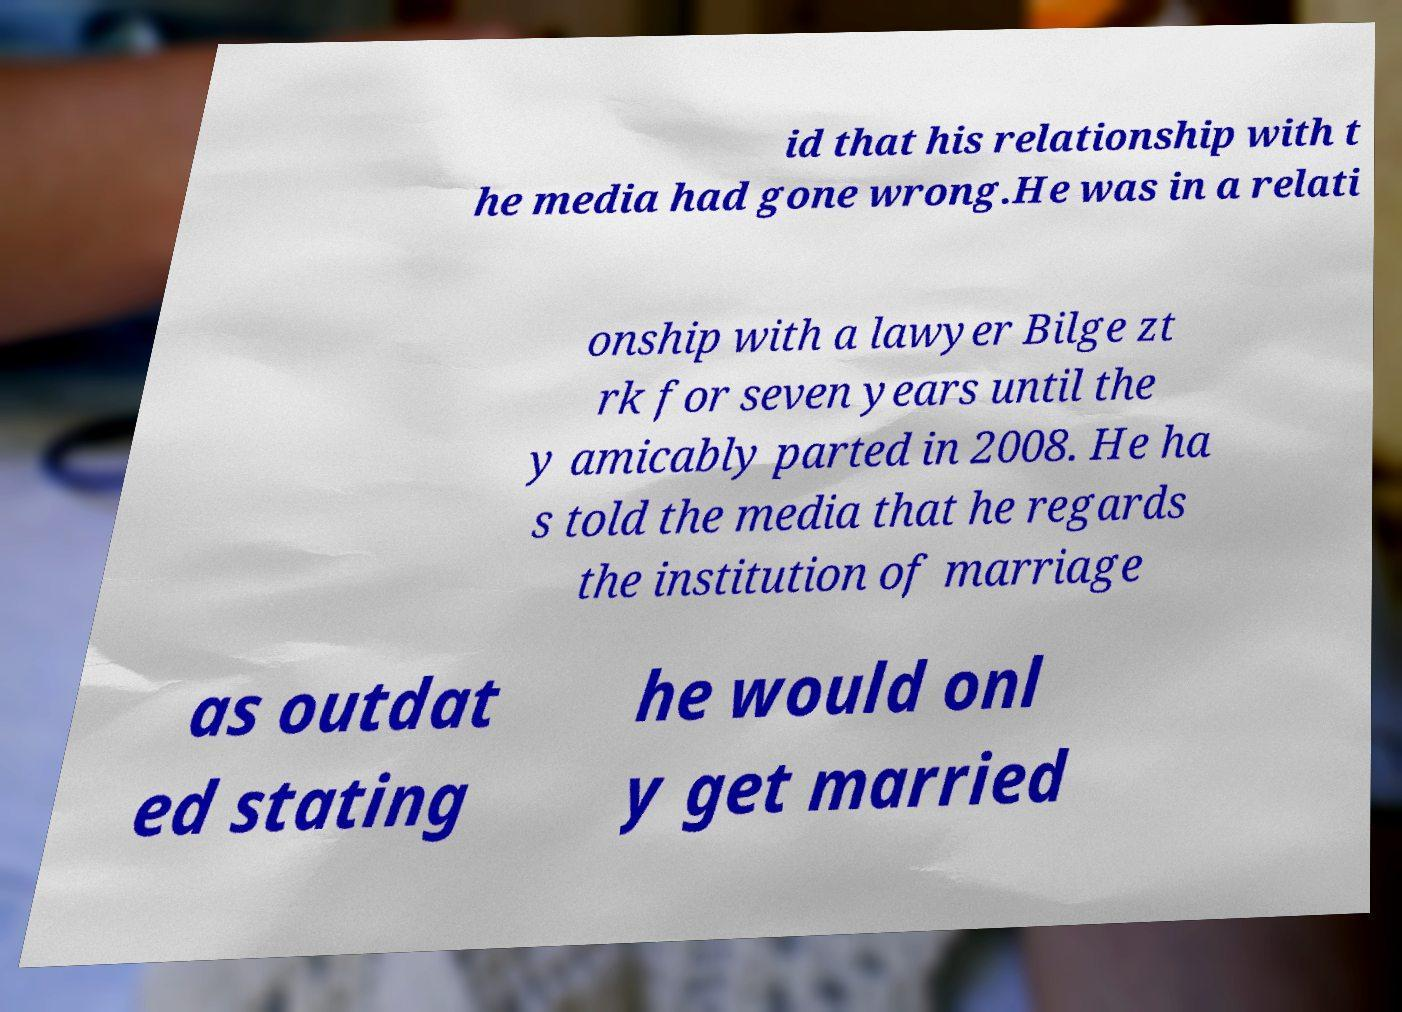What messages or text are displayed in this image? I need them in a readable, typed format. id that his relationship with t he media had gone wrong.He was in a relati onship with a lawyer Bilge zt rk for seven years until the y amicably parted in 2008. He ha s told the media that he regards the institution of marriage as outdat ed stating he would onl y get married 